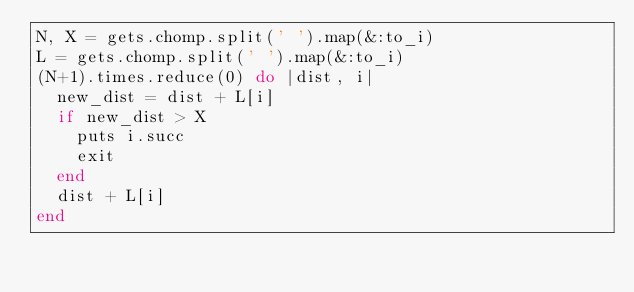Convert code to text. <code><loc_0><loc_0><loc_500><loc_500><_Ruby_>N, X = gets.chomp.split(' ').map(&:to_i)
L = gets.chomp.split(' ').map(&:to_i)
(N+1).times.reduce(0) do |dist, i|
  new_dist = dist + L[i]
  if new_dist > X
    puts i.succ
    exit
  end
  dist + L[i]
end</code> 